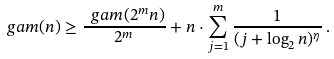Convert formula to latex. <formula><loc_0><loc_0><loc_500><loc_500>\ g a m ( n ) \geq \frac { \ g a m ( 2 ^ { m } n ) } { 2 ^ { m } } + n \cdot \sum _ { j = 1 } ^ { m } \frac { 1 } { ( j + \log _ { 2 } n ) ^ { \eta } } \, .</formula> 